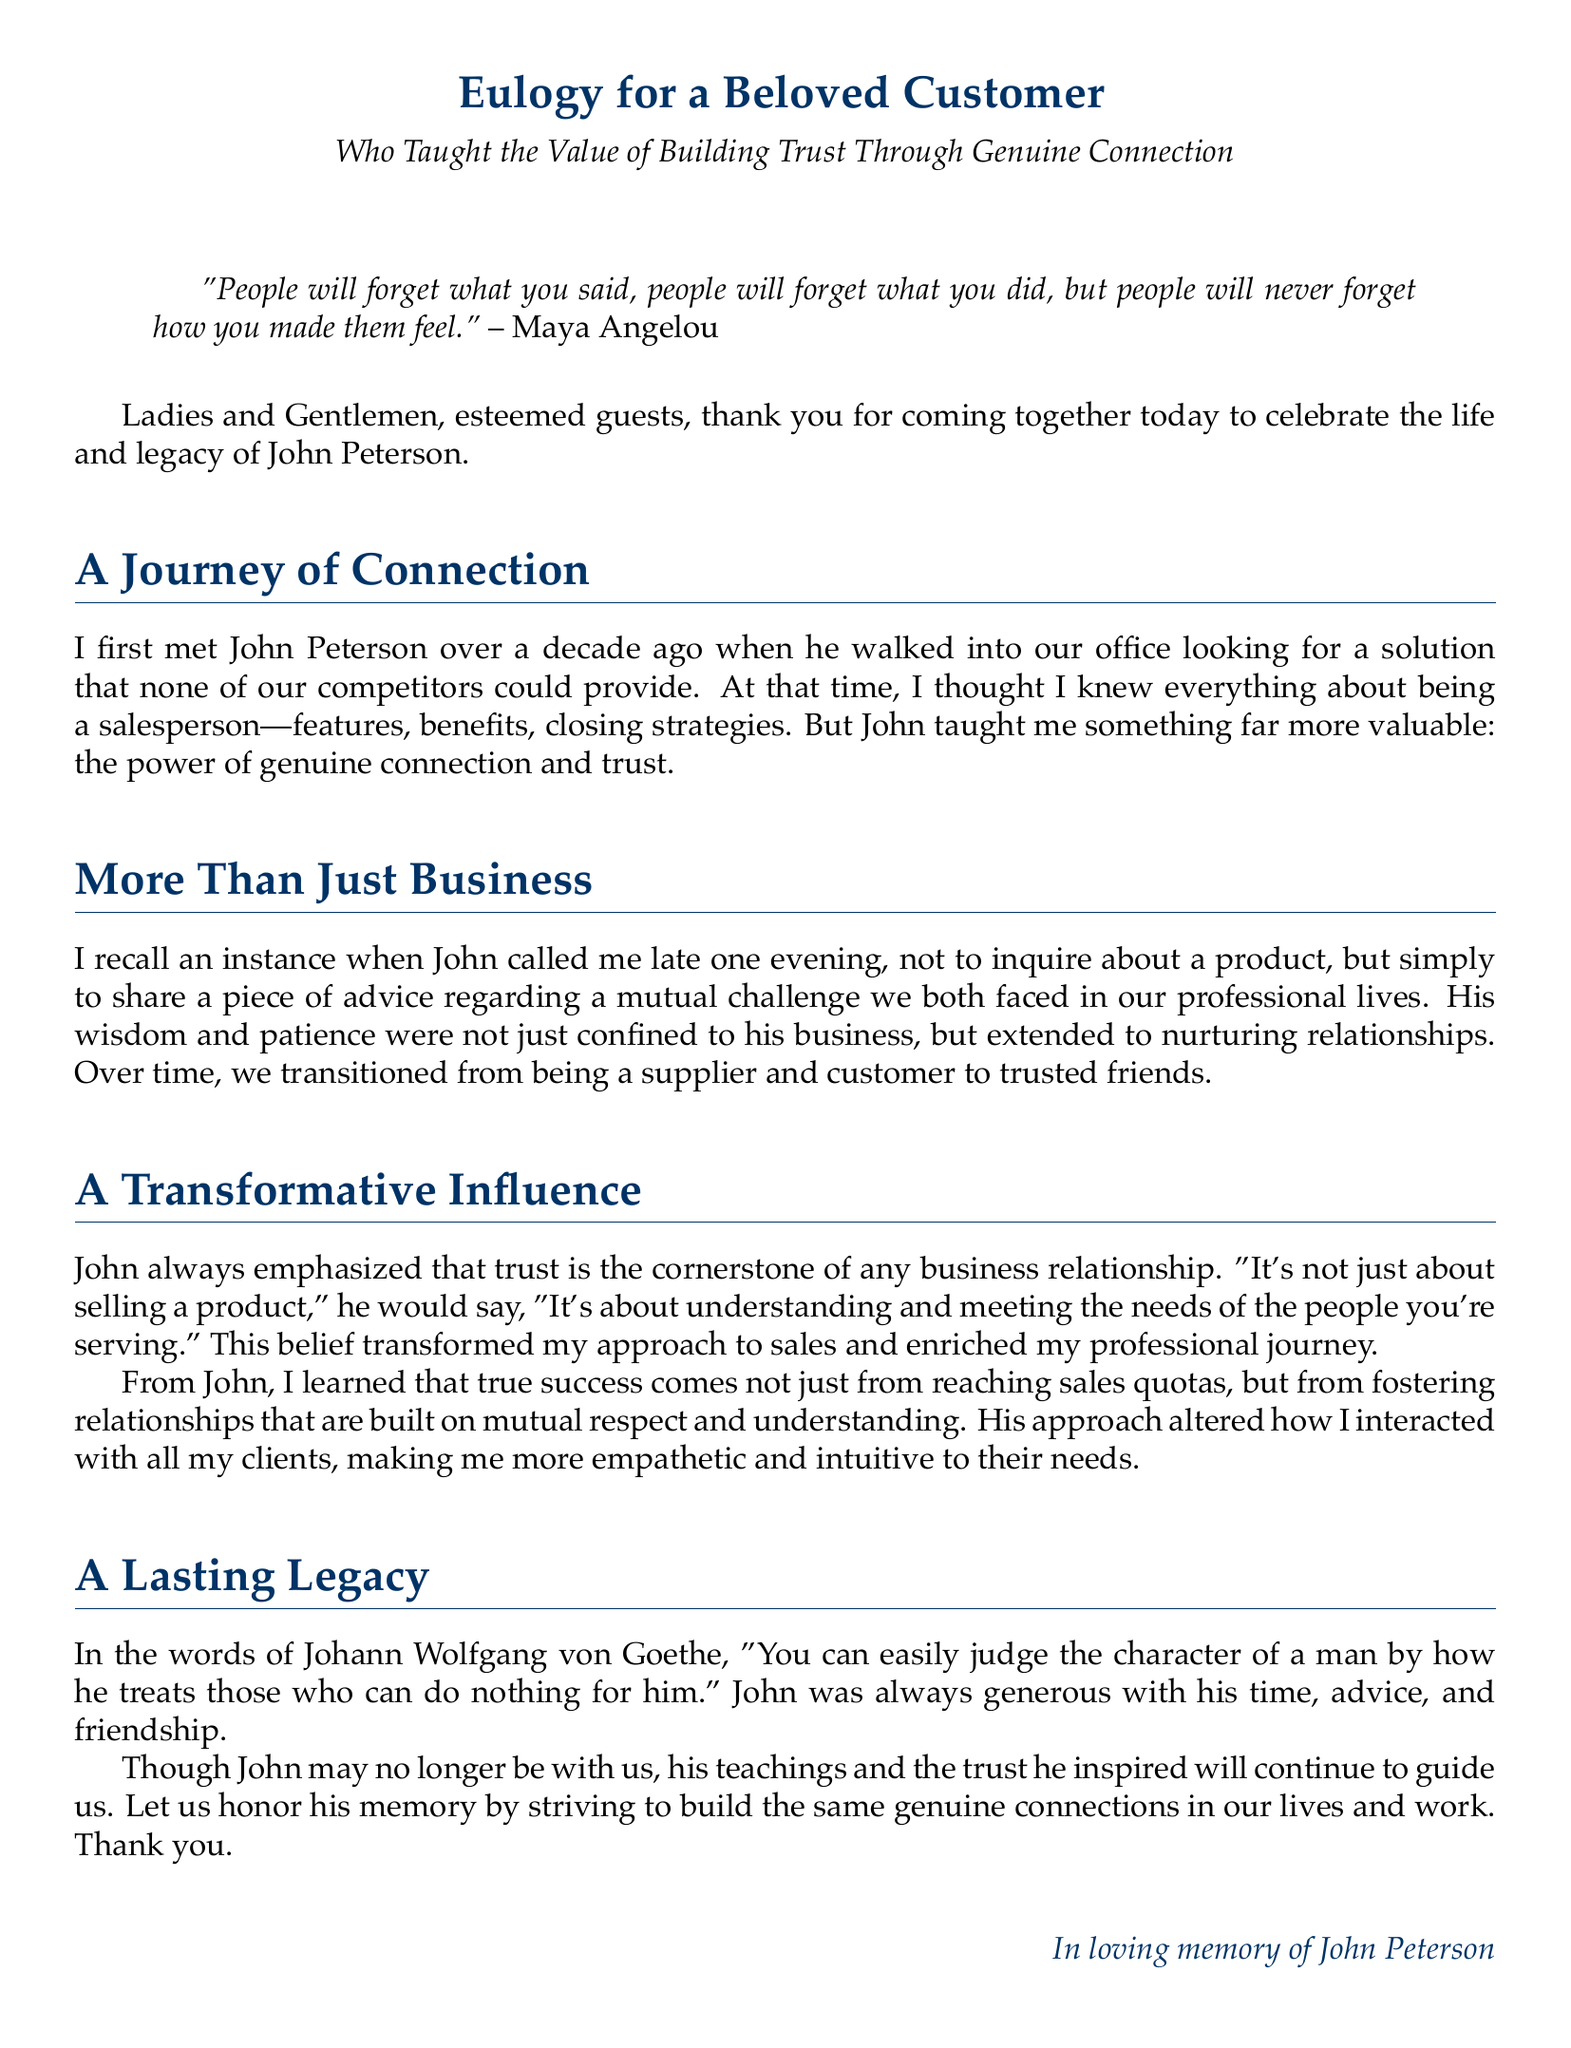What is the name of the beloved customer? The document mentions the beloved customer as John Peterson.
Answer: John Peterson Who is quoted in the document? The document includes a quote from Maya Angelou.
Answer: Maya Angelou How many years ago did the speaker first meet John? The speaker states they met John over a decade ago.
Answer: over a decade What did John emphasize as the cornerstone of business relationships? The document states that John emphasized trust as the cornerstone.
Answer: Trust What did John call the speaker late one evening to discuss? John called the speaker to share advice regarding a mutual challenge.
Answer: advice regarding a mutual challenge What is the last name of John in the document? The document reveals John's last name as Peterson.
Answer: Peterson Which author's quote is used in the eulogy? The document mentions a quote from Johann Wolfgang von Goethe.
Answer: Johann Wolfgang von Goethe What kind of connections does the speaker encourage to honor John's memory? The speaker encourages building genuine connections in our lives and work.
Answer: genuine connections 